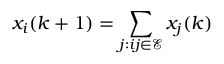Convert formula to latex. <formula><loc_0><loc_0><loc_500><loc_500>x _ { i } ( k + 1 ) = \sum _ { j \colon i j \in \mathcal { E } } x _ { j } ( k )</formula> 